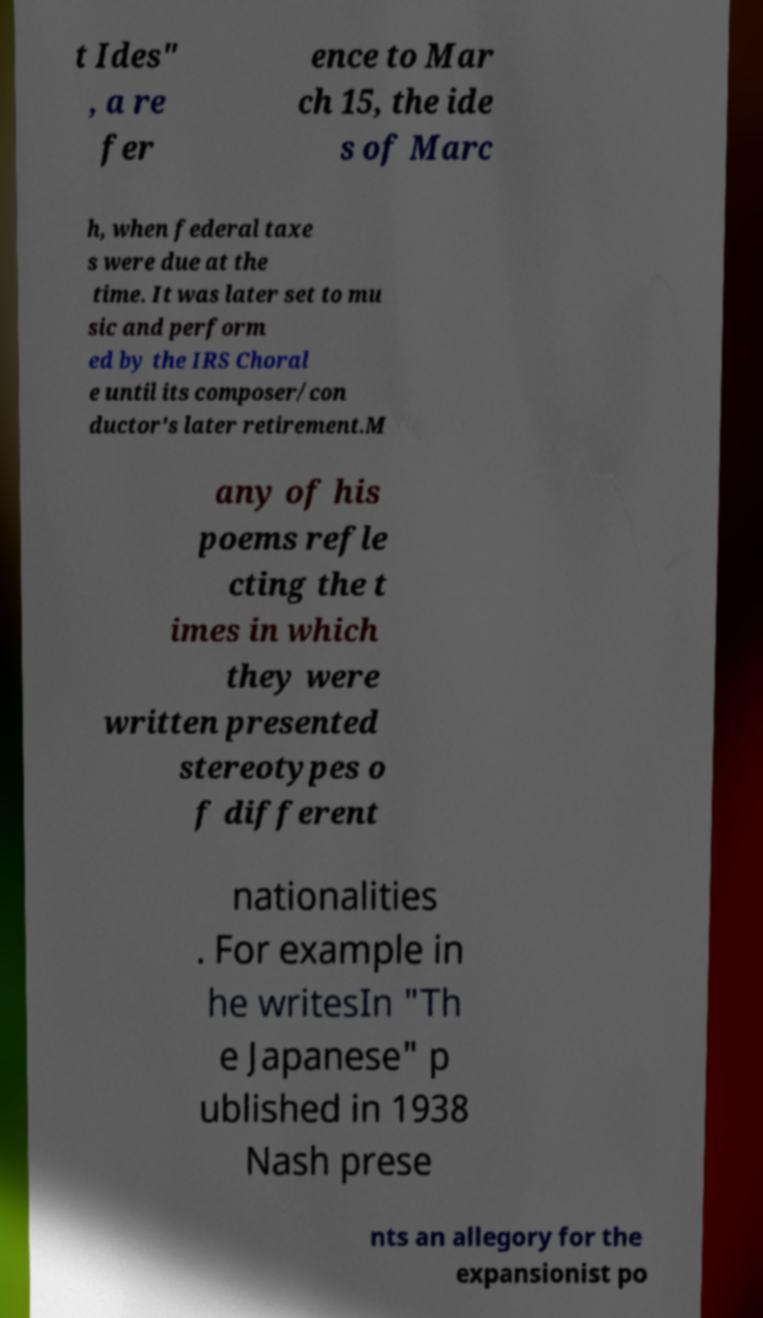Can you accurately transcribe the text from the provided image for me? t Ides" , a re fer ence to Mar ch 15, the ide s of Marc h, when federal taxe s were due at the time. It was later set to mu sic and perform ed by the IRS Choral e until its composer/con ductor's later retirement.M any of his poems refle cting the t imes in which they were written presented stereotypes o f different nationalities . For example in he writesIn "Th e Japanese" p ublished in 1938 Nash prese nts an allegory for the expansionist po 